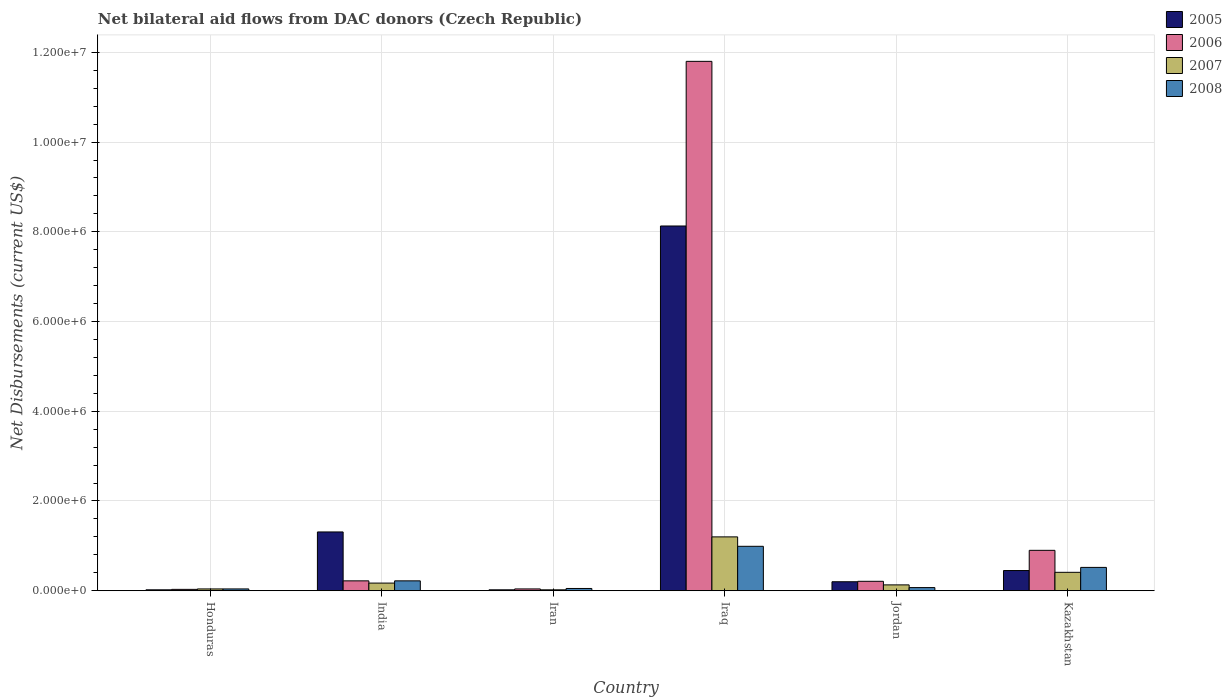How many different coloured bars are there?
Your answer should be compact. 4. How many groups of bars are there?
Give a very brief answer. 6. Are the number of bars per tick equal to the number of legend labels?
Offer a terse response. Yes. Are the number of bars on each tick of the X-axis equal?
Offer a terse response. Yes. How many bars are there on the 1st tick from the right?
Offer a very short reply. 4. What is the label of the 4th group of bars from the left?
Offer a terse response. Iraq. In how many cases, is the number of bars for a given country not equal to the number of legend labels?
Keep it short and to the point. 0. Across all countries, what is the maximum net bilateral aid flows in 2007?
Make the answer very short. 1.20e+06. In which country was the net bilateral aid flows in 2007 maximum?
Provide a short and direct response. Iraq. In which country was the net bilateral aid flows in 2007 minimum?
Offer a terse response. Iran. What is the total net bilateral aid flows in 2006 in the graph?
Keep it short and to the point. 1.32e+07. What is the difference between the net bilateral aid flows in 2005 in Honduras and that in India?
Make the answer very short. -1.29e+06. What is the difference between the net bilateral aid flows in 2007 in Honduras and the net bilateral aid flows in 2006 in Iraq?
Keep it short and to the point. -1.18e+07. What is the average net bilateral aid flows in 2007 per country?
Offer a very short reply. 3.28e+05. In how many countries, is the net bilateral aid flows in 2005 greater than 3200000 US$?
Give a very brief answer. 1. What is the ratio of the net bilateral aid flows in 2008 in Iraq to that in Kazakhstan?
Give a very brief answer. 1.9. Is the net bilateral aid flows in 2006 in Honduras less than that in Iran?
Provide a succinct answer. Yes. Is the difference between the net bilateral aid flows in 2008 in India and Iraq greater than the difference between the net bilateral aid flows in 2006 in India and Iraq?
Provide a succinct answer. Yes. What is the difference between the highest and the second highest net bilateral aid flows in 2005?
Keep it short and to the point. 6.82e+06. What is the difference between the highest and the lowest net bilateral aid flows in 2007?
Make the answer very short. 1.18e+06. Is it the case that in every country, the sum of the net bilateral aid flows in 2008 and net bilateral aid flows in 2005 is greater than the sum of net bilateral aid flows in 2006 and net bilateral aid flows in 2007?
Offer a very short reply. No. What does the 2nd bar from the right in India represents?
Provide a succinct answer. 2007. Is it the case that in every country, the sum of the net bilateral aid flows in 2006 and net bilateral aid flows in 2005 is greater than the net bilateral aid flows in 2007?
Your response must be concise. Yes. How many bars are there?
Make the answer very short. 24. Are all the bars in the graph horizontal?
Your answer should be compact. No. How many countries are there in the graph?
Provide a short and direct response. 6. Are the values on the major ticks of Y-axis written in scientific E-notation?
Ensure brevity in your answer.  Yes. What is the title of the graph?
Offer a very short reply. Net bilateral aid flows from DAC donors (Czech Republic). What is the label or title of the Y-axis?
Provide a succinct answer. Net Disbursements (current US$). What is the Net Disbursements (current US$) in 2006 in Honduras?
Provide a short and direct response. 3.00e+04. What is the Net Disbursements (current US$) in 2008 in Honduras?
Give a very brief answer. 4.00e+04. What is the Net Disbursements (current US$) in 2005 in India?
Your response must be concise. 1.31e+06. What is the Net Disbursements (current US$) of 2007 in India?
Offer a terse response. 1.70e+05. What is the Net Disbursements (current US$) of 2005 in Iran?
Give a very brief answer. 2.00e+04. What is the Net Disbursements (current US$) in 2008 in Iran?
Provide a short and direct response. 5.00e+04. What is the Net Disbursements (current US$) in 2005 in Iraq?
Your answer should be compact. 8.13e+06. What is the Net Disbursements (current US$) of 2006 in Iraq?
Offer a very short reply. 1.18e+07. What is the Net Disbursements (current US$) in 2007 in Iraq?
Offer a terse response. 1.20e+06. What is the Net Disbursements (current US$) in 2008 in Iraq?
Give a very brief answer. 9.90e+05. What is the Net Disbursements (current US$) in 2005 in Jordan?
Offer a terse response. 2.00e+05. What is the Net Disbursements (current US$) of 2007 in Kazakhstan?
Your response must be concise. 4.10e+05. What is the Net Disbursements (current US$) of 2008 in Kazakhstan?
Your answer should be very brief. 5.20e+05. Across all countries, what is the maximum Net Disbursements (current US$) in 2005?
Your answer should be very brief. 8.13e+06. Across all countries, what is the maximum Net Disbursements (current US$) in 2006?
Provide a succinct answer. 1.18e+07. Across all countries, what is the maximum Net Disbursements (current US$) in 2007?
Provide a short and direct response. 1.20e+06. Across all countries, what is the maximum Net Disbursements (current US$) in 2008?
Offer a terse response. 9.90e+05. Across all countries, what is the minimum Net Disbursements (current US$) in 2007?
Give a very brief answer. 2.00e+04. Across all countries, what is the minimum Net Disbursements (current US$) of 2008?
Ensure brevity in your answer.  4.00e+04. What is the total Net Disbursements (current US$) of 2005 in the graph?
Ensure brevity in your answer.  1.01e+07. What is the total Net Disbursements (current US$) of 2006 in the graph?
Ensure brevity in your answer.  1.32e+07. What is the total Net Disbursements (current US$) in 2007 in the graph?
Provide a short and direct response. 1.97e+06. What is the total Net Disbursements (current US$) of 2008 in the graph?
Provide a short and direct response. 1.89e+06. What is the difference between the Net Disbursements (current US$) in 2005 in Honduras and that in India?
Provide a succinct answer. -1.29e+06. What is the difference between the Net Disbursements (current US$) in 2006 in Honduras and that in India?
Your response must be concise. -1.90e+05. What is the difference between the Net Disbursements (current US$) of 2007 in Honduras and that in India?
Your answer should be compact. -1.30e+05. What is the difference between the Net Disbursements (current US$) of 2006 in Honduras and that in Iran?
Your answer should be compact. -10000. What is the difference between the Net Disbursements (current US$) in 2007 in Honduras and that in Iran?
Offer a very short reply. 2.00e+04. What is the difference between the Net Disbursements (current US$) in 2005 in Honduras and that in Iraq?
Offer a very short reply. -8.11e+06. What is the difference between the Net Disbursements (current US$) in 2006 in Honduras and that in Iraq?
Provide a succinct answer. -1.18e+07. What is the difference between the Net Disbursements (current US$) of 2007 in Honduras and that in Iraq?
Your answer should be compact. -1.16e+06. What is the difference between the Net Disbursements (current US$) in 2008 in Honduras and that in Iraq?
Provide a succinct answer. -9.50e+05. What is the difference between the Net Disbursements (current US$) in 2005 in Honduras and that in Jordan?
Provide a succinct answer. -1.80e+05. What is the difference between the Net Disbursements (current US$) of 2006 in Honduras and that in Jordan?
Offer a very short reply. -1.80e+05. What is the difference between the Net Disbursements (current US$) in 2007 in Honduras and that in Jordan?
Provide a succinct answer. -9.00e+04. What is the difference between the Net Disbursements (current US$) in 2008 in Honduras and that in Jordan?
Give a very brief answer. -3.00e+04. What is the difference between the Net Disbursements (current US$) of 2005 in Honduras and that in Kazakhstan?
Offer a very short reply. -4.30e+05. What is the difference between the Net Disbursements (current US$) of 2006 in Honduras and that in Kazakhstan?
Offer a terse response. -8.70e+05. What is the difference between the Net Disbursements (current US$) of 2007 in Honduras and that in Kazakhstan?
Offer a terse response. -3.70e+05. What is the difference between the Net Disbursements (current US$) in 2008 in Honduras and that in Kazakhstan?
Your response must be concise. -4.80e+05. What is the difference between the Net Disbursements (current US$) of 2005 in India and that in Iran?
Provide a short and direct response. 1.29e+06. What is the difference between the Net Disbursements (current US$) of 2005 in India and that in Iraq?
Provide a succinct answer. -6.82e+06. What is the difference between the Net Disbursements (current US$) of 2006 in India and that in Iraq?
Give a very brief answer. -1.16e+07. What is the difference between the Net Disbursements (current US$) of 2007 in India and that in Iraq?
Ensure brevity in your answer.  -1.03e+06. What is the difference between the Net Disbursements (current US$) of 2008 in India and that in Iraq?
Offer a very short reply. -7.70e+05. What is the difference between the Net Disbursements (current US$) in 2005 in India and that in Jordan?
Your answer should be compact. 1.11e+06. What is the difference between the Net Disbursements (current US$) in 2006 in India and that in Jordan?
Offer a very short reply. 10000. What is the difference between the Net Disbursements (current US$) of 2007 in India and that in Jordan?
Your answer should be compact. 4.00e+04. What is the difference between the Net Disbursements (current US$) in 2005 in India and that in Kazakhstan?
Offer a very short reply. 8.60e+05. What is the difference between the Net Disbursements (current US$) in 2006 in India and that in Kazakhstan?
Offer a terse response. -6.80e+05. What is the difference between the Net Disbursements (current US$) of 2005 in Iran and that in Iraq?
Your answer should be very brief. -8.11e+06. What is the difference between the Net Disbursements (current US$) of 2006 in Iran and that in Iraq?
Offer a very short reply. -1.18e+07. What is the difference between the Net Disbursements (current US$) in 2007 in Iran and that in Iraq?
Your response must be concise. -1.18e+06. What is the difference between the Net Disbursements (current US$) of 2008 in Iran and that in Iraq?
Give a very brief answer. -9.40e+05. What is the difference between the Net Disbursements (current US$) in 2005 in Iran and that in Jordan?
Your response must be concise. -1.80e+05. What is the difference between the Net Disbursements (current US$) in 2006 in Iran and that in Jordan?
Your response must be concise. -1.70e+05. What is the difference between the Net Disbursements (current US$) in 2007 in Iran and that in Jordan?
Provide a succinct answer. -1.10e+05. What is the difference between the Net Disbursements (current US$) of 2008 in Iran and that in Jordan?
Give a very brief answer. -2.00e+04. What is the difference between the Net Disbursements (current US$) of 2005 in Iran and that in Kazakhstan?
Ensure brevity in your answer.  -4.30e+05. What is the difference between the Net Disbursements (current US$) of 2006 in Iran and that in Kazakhstan?
Your answer should be compact. -8.60e+05. What is the difference between the Net Disbursements (current US$) of 2007 in Iran and that in Kazakhstan?
Ensure brevity in your answer.  -3.90e+05. What is the difference between the Net Disbursements (current US$) in 2008 in Iran and that in Kazakhstan?
Keep it short and to the point. -4.70e+05. What is the difference between the Net Disbursements (current US$) in 2005 in Iraq and that in Jordan?
Your answer should be compact. 7.93e+06. What is the difference between the Net Disbursements (current US$) in 2006 in Iraq and that in Jordan?
Keep it short and to the point. 1.16e+07. What is the difference between the Net Disbursements (current US$) of 2007 in Iraq and that in Jordan?
Offer a very short reply. 1.07e+06. What is the difference between the Net Disbursements (current US$) in 2008 in Iraq and that in Jordan?
Offer a very short reply. 9.20e+05. What is the difference between the Net Disbursements (current US$) of 2005 in Iraq and that in Kazakhstan?
Make the answer very short. 7.68e+06. What is the difference between the Net Disbursements (current US$) of 2006 in Iraq and that in Kazakhstan?
Give a very brief answer. 1.09e+07. What is the difference between the Net Disbursements (current US$) in 2007 in Iraq and that in Kazakhstan?
Keep it short and to the point. 7.90e+05. What is the difference between the Net Disbursements (current US$) of 2008 in Iraq and that in Kazakhstan?
Make the answer very short. 4.70e+05. What is the difference between the Net Disbursements (current US$) in 2006 in Jordan and that in Kazakhstan?
Make the answer very short. -6.90e+05. What is the difference between the Net Disbursements (current US$) of 2007 in Jordan and that in Kazakhstan?
Keep it short and to the point. -2.80e+05. What is the difference between the Net Disbursements (current US$) in 2008 in Jordan and that in Kazakhstan?
Provide a short and direct response. -4.50e+05. What is the difference between the Net Disbursements (current US$) in 2005 in Honduras and the Net Disbursements (current US$) in 2007 in India?
Your answer should be compact. -1.50e+05. What is the difference between the Net Disbursements (current US$) in 2005 in Honduras and the Net Disbursements (current US$) in 2008 in India?
Ensure brevity in your answer.  -2.00e+05. What is the difference between the Net Disbursements (current US$) of 2006 in Honduras and the Net Disbursements (current US$) of 2007 in India?
Keep it short and to the point. -1.40e+05. What is the difference between the Net Disbursements (current US$) of 2005 in Honduras and the Net Disbursements (current US$) of 2008 in Iran?
Offer a very short reply. -3.00e+04. What is the difference between the Net Disbursements (current US$) in 2006 in Honduras and the Net Disbursements (current US$) in 2008 in Iran?
Your response must be concise. -2.00e+04. What is the difference between the Net Disbursements (current US$) of 2005 in Honduras and the Net Disbursements (current US$) of 2006 in Iraq?
Offer a terse response. -1.18e+07. What is the difference between the Net Disbursements (current US$) of 2005 in Honduras and the Net Disbursements (current US$) of 2007 in Iraq?
Provide a succinct answer. -1.18e+06. What is the difference between the Net Disbursements (current US$) of 2005 in Honduras and the Net Disbursements (current US$) of 2008 in Iraq?
Ensure brevity in your answer.  -9.70e+05. What is the difference between the Net Disbursements (current US$) in 2006 in Honduras and the Net Disbursements (current US$) in 2007 in Iraq?
Keep it short and to the point. -1.17e+06. What is the difference between the Net Disbursements (current US$) of 2006 in Honduras and the Net Disbursements (current US$) of 2008 in Iraq?
Ensure brevity in your answer.  -9.60e+05. What is the difference between the Net Disbursements (current US$) in 2007 in Honduras and the Net Disbursements (current US$) in 2008 in Iraq?
Ensure brevity in your answer.  -9.50e+05. What is the difference between the Net Disbursements (current US$) of 2005 in Honduras and the Net Disbursements (current US$) of 2006 in Jordan?
Your answer should be very brief. -1.90e+05. What is the difference between the Net Disbursements (current US$) of 2005 in Honduras and the Net Disbursements (current US$) of 2007 in Jordan?
Your answer should be compact. -1.10e+05. What is the difference between the Net Disbursements (current US$) in 2006 in Honduras and the Net Disbursements (current US$) in 2007 in Jordan?
Provide a short and direct response. -1.00e+05. What is the difference between the Net Disbursements (current US$) in 2006 in Honduras and the Net Disbursements (current US$) in 2008 in Jordan?
Provide a short and direct response. -4.00e+04. What is the difference between the Net Disbursements (current US$) of 2005 in Honduras and the Net Disbursements (current US$) of 2006 in Kazakhstan?
Give a very brief answer. -8.80e+05. What is the difference between the Net Disbursements (current US$) in 2005 in Honduras and the Net Disbursements (current US$) in 2007 in Kazakhstan?
Provide a succinct answer. -3.90e+05. What is the difference between the Net Disbursements (current US$) of 2005 in Honduras and the Net Disbursements (current US$) of 2008 in Kazakhstan?
Offer a very short reply. -5.00e+05. What is the difference between the Net Disbursements (current US$) in 2006 in Honduras and the Net Disbursements (current US$) in 2007 in Kazakhstan?
Make the answer very short. -3.80e+05. What is the difference between the Net Disbursements (current US$) in 2006 in Honduras and the Net Disbursements (current US$) in 2008 in Kazakhstan?
Your answer should be compact. -4.90e+05. What is the difference between the Net Disbursements (current US$) in 2007 in Honduras and the Net Disbursements (current US$) in 2008 in Kazakhstan?
Your answer should be compact. -4.80e+05. What is the difference between the Net Disbursements (current US$) in 2005 in India and the Net Disbursements (current US$) in 2006 in Iran?
Make the answer very short. 1.27e+06. What is the difference between the Net Disbursements (current US$) in 2005 in India and the Net Disbursements (current US$) in 2007 in Iran?
Provide a short and direct response. 1.29e+06. What is the difference between the Net Disbursements (current US$) of 2005 in India and the Net Disbursements (current US$) of 2008 in Iran?
Make the answer very short. 1.26e+06. What is the difference between the Net Disbursements (current US$) of 2006 in India and the Net Disbursements (current US$) of 2008 in Iran?
Provide a succinct answer. 1.70e+05. What is the difference between the Net Disbursements (current US$) of 2005 in India and the Net Disbursements (current US$) of 2006 in Iraq?
Your answer should be compact. -1.05e+07. What is the difference between the Net Disbursements (current US$) in 2005 in India and the Net Disbursements (current US$) in 2008 in Iraq?
Offer a very short reply. 3.20e+05. What is the difference between the Net Disbursements (current US$) in 2006 in India and the Net Disbursements (current US$) in 2007 in Iraq?
Keep it short and to the point. -9.80e+05. What is the difference between the Net Disbursements (current US$) in 2006 in India and the Net Disbursements (current US$) in 2008 in Iraq?
Your answer should be compact. -7.70e+05. What is the difference between the Net Disbursements (current US$) in 2007 in India and the Net Disbursements (current US$) in 2008 in Iraq?
Offer a terse response. -8.20e+05. What is the difference between the Net Disbursements (current US$) of 2005 in India and the Net Disbursements (current US$) of 2006 in Jordan?
Give a very brief answer. 1.10e+06. What is the difference between the Net Disbursements (current US$) of 2005 in India and the Net Disbursements (current US$) of 2007 in Jordan?
Offer a terse response. 1.18e+06. What is the difference between the Net Disbursements (current US$) of 2005 in India and the Net Disbursements (current US$) of 2008 in Jordan?
Give a very brief answer. 1.24e+06. What is the difference between the Net Disbursements (current US$) in 2006 in India and the Net Disbursements (current US$) in 2007 in Jordan?
Ensure brevity in your answer.  9.00e+04. What is the difference between the Net Disbursements (current US$) of 2007 in India and the Net Disbursements (current US$) of 2008 in Jordan?
Make the answer very short. 1.00e+05. What is the difference between the Net Disbursements (current US$) of 2005 in India and the Net Disbursements (current US$) of 2008 in Kazakhstan?
Offer a very short reply. 7.90e+05. What is the difference between the Net Disbursements (current US$) of 2006 in India and the Net Disbursements (current US$) of 2007 in Kazakhstan?
Ensure brevity in your answer.  -1.90e+05. What is the difference between the Net Disbursements (current US$) of 2006 in India and the Net Disbursements (current US$) of 2008 in Kazakhstan?
Provide a succinct answer. -3.00e+05. What is the difference between the Net Disbursements (current US$) of 2007 in India and the Net Disbursements (current US$) of 2008 in Kazakhstan?
Provide a short and direct response. -3.50e+05. What is the difference between the Net Disbursements (current US$) of 2005 in Iran and the Net Disbursements (current US$) of 2006 in Iraq?
Offer a very short reply. -1.18e+07. What is the difference between the Net Disbursements (current US$) of 2005 in Iran and the Net Disbursements (current US$) of 2007 in Iraq?
Ensure brevity in your answer.  -1.18e+06. What is the difference between the Net Disbursements (current US$) of 2005 in Iran and the Net Disbursements (current US$) of 2008 in Iraq?
Offer a very short reply. -9.70e+05. What is the difference between the Net Disbursements (current US$) in 2006 in Iran and the Net Disbursements (current US$) in 2007 in Iraq?
Ensure brevity in your answer.  -1.16e+06. What is the difference between the Net Disbursements (current US$) in 2006 in Iran and the Net Disbursements (current US$) in 2008 in Iraq?
Make the answer very short. -9.50e+05. What is the difference between the Net Disbursements (current US$) of 2007 in Iran and the Net Disbursements (current US$) of 2008 in Iraq?
Provide a succinct answer. -9.70e+05. What is the difference between the Net Disbursements (current US$) in 2005 in Iran and the Net Disbursements (current US$) in 2006 in Jordan?
Offer a terse response. -1.90e+05. What is the difference between the Net Disbursements (current US$) of 2006 in Iran and the Net Disbursements (current US$) of 2008 in Jordan?
Give a very brief answer. -3.00e+04. What is the difference between the Net Disbursements (current US$) of 2007 in Iran and the Net Disbursements (current US$) of 2008 in Jordan?
Offer a terse response. -5.00e+04. What is the difference between the Net Disbursements (current US$) in 2005 in Iran and the Net Disbursements (current US$) in 2006 in Kazakhstan?
Offer a very short reply. -8.80e+05. What is the difference between the Net Disbursements (current US$) of 2005 in Iran and the Net Disbursements (current US$) of 2007 in Kazakhstan?
Your answer should be very brief. -3.90e+05. What is the difference between the Net Disbursements (current US$) in 2005 in Iran and the Net Disbursements (current US$) in 2008 in Kazakhstan?
Give a very brief answer. -5.00e+05. What is the difference between the Net Disbursements (current US$) of 2006 in Iran and the Net Disbursements (current US$) of 2007 in Kazakhstan?
Provide a succinct answer. -3.70e+05. What is the difference between the Net Disbursements (current US$) in 2006 in Iran and the Net Disbursements (current US$) in 2008 in Kazakhstan?
Provide a succinct answer. -4.80e+05. What is the difference between the Net Disbursements (current US$) in 2007 in Iran and the Net Disbursements (current US$) in 2008 in Kazakhstan?
Offer a terse response. -5.00e+05. What is the difference between the Net Disbursements (current US$) of 2005 in Iraq and the Net Disbursements (current US$) of 2006 in Jordan?
Make the answer very short. 7.92e+06. What is the difference between the Net Disbursements (current US$) in 2005 in Iraq and the Net Disbursements (current US$) in 2007 in Jordan?
Keep it short and to the point. 8.00e+06. What is the difference between the Net Disbursements (current US$) of 2005 in Iraq and the Net Disbursements (current US$) of 2008 in Jordan?
Provide a short and direct response. 8.06e+06. What is the difference between the Net Disbursements (current US$) of 2006 in Iraq and the Net Disbursements (current US$) of 2007 in Jordan?
Provide a short and direct response. 1.17e+07. What is the difference between the Net Disbursements (current US$) of 2006 in Iraq and the Net Disbursements (current US$) of 2008 in Jordan?
Your answer should be very brief. 1.17e+07. What is the difference between the Net Disbursements (current US$) in 2007 in Iraq and the Net Disbursements (current US$) in 2008 in Jordan?
Make the answer very short. 1.13e+06. What is the difference between the Net Disbursements (current US$) of 2005 in Iraq and the Net Disbursements (current US$) of 2006 in Kazakhstan?
Provide a short and direct response. 7.23e+06. What is the difference between the Net Disbursements (current US$) in 2005 in Iraq and the Net Disbursements (current US$) in 2007 in Kazakhstan?
Ensure brevity in your answer.  7.72e+06. What is the difference between the Net Disbursements (current US$) in 2005 in Iraq and the Net Disbursements (current US$) in 2008 in Kazakhstan?
Ensure brevity in your answer.  7.61e+06. What is the difference between the Net Disbursements (current US$) in 2006 in Iraq and the Net Disbursements (current US$) in 2007 in Kazakhstan?
Give a very brief answer. 1.14e+07. What is the difference between the Net Disbursements (current US$) of 2006 in Iraq and the Net Disbursements (current US$) of 2008 in Kazakhstan?
Make the answer very short. 1.13e+07. What is the difference between the Net Disbursements (current US$) of 2007 in Iraq and the Net Disbursements (current US$) of 2008 in Kazakhstan?
Give a very brief answer. 6.80e+05. What is the difference between the Net Disbursements (current US$) in 2005 in Jordan and the Net Disbursements (current US$) in 2006 in Kazakhstan?
Ensure brevity in your answer.  -7.00e+05. What is the difference between the Net Disbursements (current US$) of 2005 in Jordan and the Net Disbursements (current US$) of 2007 in Kazakhstan?
Offer a terse response. -2.10e+05. What is the difference between the Net Disbursements (current US$) in 2005 in Jordan and the Net Disbursements (current US$) in 2008 in Kazakhstan?
Give a very brief answer. -3.20e+05. What is the difference between the Net Disbursements (current US$) in 2006 in Jordan and the Net Disbursements (current US$) in 2007 in Kazakhstan?
Your response must be concise. -2.00e+05. What is the difference between the Net Disbursements (current US$) of 2006 in Jordan and the Net Disbursements (current US$) of 2008 in Kazakhstan?
Your answer should be very brief. -3.10e+05. What is the difference between the Net Disbursements (current US$) of 2007 in Jordan and the Net Disbursements (current US$) of 2008 in Kazakhstan?
Your answer should be compact. -3.90e+05. What is the average Net Disbursements (current US$) in 2005 per country?
Keep it short and to the point. 1.69e+06. What is the average Net Disbursements (current US$) of 2006 per country?
Provide a succinct answer. 2.20e+06. What is the average Net Disbursements (current US$) of 2007 per country?
Make the answer very short. 3.28e+05. What is the average Net Disbursements (current US$) of 2008 per country?
Offer a very short reply. 3.15e+05. What is the difference between the Net Disbursements (current US$) of 2005 and Net Disbursements (current US$) of 2008 in Honduras?
Keep it short and to the point. -2.00e+04. What is the difference between the Net Disbursements (current US$) in 2007 and Net Disbursements (current US$) in 2008 in Honduras?
Make the answer very short. 0. What is the difference between the Net Disbursements (current US$) in 2005 and Net Disbursements (current US$) in 2006 in India?
Make the answer very short. 1.09e+06. What is the difference between the Net Disbursements (current US$) in 2005 and Net Disbursements (current US$) in 2007 in India?
Ensure brevity in your answer.  1.14e+06. What is the difference between the Net Disbursements (current US$) of 2005 and Net Disbursements (current US$) of 2008 in India?
Offer a terse response. 1.09e+06. What is the difference between the Net Disbursements (current US$) of 2006 and Net Disbursements (current US$) of 2007 in India?
Your answer should be very brief. 5.00e+04. What is the difference between the Net Disbursements (current US$) in 2006 and Net Disbursements (current US$) in 2008 in India?
Offer a terse response. 0. What is the difference between the Net Disbursements (current US$) of 2007 and Net Disbursements (current US$) of 2008 in India?
Give a very brief answer. -5.00e+04. What is the difference between the Net Disbursements (current US$) of 2005 and Net Disbursements (current US$) of 2007 in Iran?
Your answer should be compact. 0. What is the difference between the Net Disbursements (current US$) of 2005 and Net Disbursements (current US$) of 2008 in Iran?
Offer a terse response. -3.00e+04. What is the difference between the Net Disbursements (current US$) in 2006 and Net Disbursements (current US$) in 2007 in Iran?
Make the answer very short. 2.00e+04. What is the difference between the Net Disbursements (current US$) in 2006 and Net Disbursements (current US$) in 2008 in Iran?
Your answer should be compact. -10000. What is the difference between the Net Disbursements (current US$) of 2007 and Net Disbursements (current US$) of 2008 in Iran?
Your answer should be compact. -3.00e+04. What is the difference between the Net Disbursements (current US$) of 2005 and Net Disbursements (current US$) of 2006 in Iraq?
Provide a short and direct response. -3.67e+06. What is the difference between the Net Disbursements (current US$) of 2005 and Net Disbursements (current US$) of 2007 in Iraq?
Your answer should be compact. 6.93e+06. What is the difference between the Net Disbursements (current US$) of 2005 and Net Disbursements (current US$) of 2008 in Iraq?
Ensure brevity in your answer.  7.14e+06. What is the difference between the Net Disbursements (current US$) of 2006 and Net Disbursements (current US$) of 2007 in Iraq?
Your answer should be compact. 1.06e+07. What is the difference between the Net Disbursements (current US$) in 2006 and Net Disbursements (current US$) in 2008 in Iraq?
Offer a terse response. 1.08e+07. What is the difference between the Net Disbursements (current US$) of 2007 and Net Disbursements (current US$) of 2008 in Iraq?
Provide a short and direct response. 2.10e+05. What is the difference between the Net Disbursements (current US$) in 2005 and Net Disbursements (current US$) in 2008 in Jordan?
Make the answer very short. 1.30e+05. What is the difference between the Net Disbursements (current US$) of 2006 and Net Disbursements (current US$) of 2007 in Jordan?
Give a very brief answer. 8.00e+04. What is the difference between the Net Disbursements (current US$) of 2006 and Net Disbursements (current US$) of 2008 in Jordan?
Offer a very short reply. 1.40e+05. What is the difference between the Net Disbursements (current US$) in 2005 and Net Disbursements (current US$) in 2006 in Kazakhstan?
Your answer should be very brief. -4.50e+05. What is the difference between the Net Disbursements (current US$) of 2007 and Net Disbursements (current US$) of 2008 in Kazakhstan?
Ensure brevity in your answer.  -1.10e+05. What is the ratio of the Net Disbursements (current US$) in 2005 in Honduras to that in India?
Provide a short and direct response. 0.02. What is the ratio of the Net Disbursements (current US$) in 2006 in Honduras to that in India?
Offer a terse response. 0.14. What is the ratio of the Net Disbursements (current US$) of 2007 in Honduras to that in India?
Offer a very short reply. 0.24. What is the ratio of the Net Disbursements (current US$) in 2008 in Honduras to that in India?
Your answer should be compact. 0.18. What is the ratio of the Net Disbursements (current US$) in 2006 in Honduras to that in Iran?
Provide a succinct answer. 0.75. What is the ratio of the Net Disbursements (current US$) of 2005 in Honduras to that in Iraq?
Make the answer very short. 0. What is the ratio of the Net Disbursements (current US$) in 2006 in Honduras to that in Iraq?
Give a very brief answer. 0. What is the ratio of the Net Disbursements (current US$) in 2008 in Honduras to that in Iraq?
Offer a terse response. 0.04. What is the ratio of the Net Disbursements (current US$) of 2006 in Honduras to that in Jordan?
Keep it short and to the point. 0.14. What is the ratio of the Net Disbursements (current US$) in 2007 in Honduras to that in Jordan?
Ensure brevity in your answer.  0.31. What is the ratio of the Net Disbursements (current US$) of 2005 in Honduras to that in Kazakhstan?
Give a very brief answer. 0.04. What is the ratio of the Net Disbursements (current US$) of 2007 in Honduras to that in Kazakhstan?
Offer a terse response. 0.1. What is the ratio of the Net Disbursements (current US$) of 2008 in Honduras to that in Kazakhstan?
Offer a very short reply. 0.08. What is the ratio of the Net Disbursements (current US$) in 2005 in India to that in Iran?
Offer a terse response. 65.5. What is the ratio of the Net Disbursements (current US$) of 2007 in India to that in Iran?
Offer a very short reply. 8.5. What is the ratio of the Net Disbursements (current US$) in 2008 in India to that in Iran?
Offer a very short reply. 4.4. What is the ratio of the Net Disbursements (current US$) of 2005 in India to that in Iraq?
Make the answer very short. 0.16. What is the ratio of the Net Disbursements (current US$) in 2006 in India to that in Iraq?
Your response must be concise. 0.02. What is the ratio of the Net Disbursements (current US$) in 2007 in India to that in Iraq?
Make the answer very short. 0.14. What is the ratio of the Net Disbursements (current US$) in 2008 in India to that in Iraq?
Offer a very short reply. 0.22. What is the ratio of the Net Disbursements (current US$) in 2005 in India to that in Jordan?
Offer a terse response. 6.55. What is the ratio of the Net Disbursements (current US$) of 2006 in India to that in Jordan?
Ensure brevity in your answer.  1.05. What is the ratio of the Net Disbursements (current US$) of 2007 in India to that in Jordan?
Your response must be concise. 1.31. What is the ratio of the Net Disbursements (current US$) in 2008 in India to that in Jordan?
Your answer should be compact. 3.14. What is the ratio of the Net Disbursements (current US$) of 2005 in India to that in Kazakhstan?
Your response must be concise. 2.91. What is the ratio of the Net Disbursements (current US$) in 2006 in India to that in Kazakhstan?
Offer a very short reply. 0.24. What is the ratio of the Net Disbursements (current US$) in 2007 in India to that in Kazakhstan?
Offer a terse response. 0.41. What is the ratio of the Net Disbursements (current US$) in 2008 in India to that in Kazakhstan?
Keep it short and to the point. 0.42. What is the ratio of the Net Disbursements (current US$) of 2005 in Iran to that in Iraq?
Your answer should be very brief. 0. What is the ratio of the Net Disbursements (current US$) in 2006 in Iran to that in Iraq?
Provide a short and direct response. 0. What is the ratio of the Net Disbursements (current US$) in 2007 in Iran to that in Iraq?
Offer a very short reply. 0.02. What is the ratio of the Net Disbursements (current US$) in 2008 in Iran to that in Iraq?
Offer a terse response. 0.05. What is the ratio of the Net Disbursements (current US$) in 2006 in Iran to that in Jordan?
Your answer should be very brief. 0.19. What is the ratio of the Net Disbursements (current US$) of 2007 in Iran to that in Jordan?
Give a very brief answer. 0.15. What is the ratio of the Net Disbursements (current US$) in 2005 in Iran to that in Kazakhstan?
Offer a terse response. 0.04. What is the ratio of the Net Disbursements (current US$) in 2006 in Iran to that in Kazakhstan?
Give a very brief answer. 0.04. What is the ratio of the Net Disbursements (current US$) of 2007 in Iran to that in Kazakhstan?
Offer a very short reply. 0.05. What is the ratio of the Net Disbursements (current US$) in 2008 in Iran to that in Kazakhstan?
Your answer should be compact. 0.1. What is the ratio of the Net Disbursements (current US$) in 2005 in Iraq to that in Jordan?
Provide a short and direct response. 40.65. What is the ratio of the Net Disbursements (current US$) of 2006 in Iraq to that in Jordan?
Give a very brief answer. 56.19. What is the ratio of the Net Disbursements (current US$) of 2007 in Iraq to that in Jordan?
Your answer should be very brief. 9.23. What is the ratio of the Net Disbursements (current US$) of 2008 in Iraq to that in Jordan?
Offer a terse response. 14.14. What is the ratio of the Net Disbursements (current US$) of 2005 in Iraq to that in Kazakhstan?
Offer a very short reply. 18.07. What is the ratio of the Net Disbursements (current US$) in 2006 in Iraq to that in Kazakhstan?
Provide a succinct answer. 13.11. What is the ratio of the Net Disbursements (current US$) in 2007 in Iraq to that in Kazakhstan?
Keep it short and to the point. 2.93. What is the ratio of the Net Disbursements (current US$) of 2008 in Iraq to that in Kazakhstan?
Your response must be concise. 1.9. What is the ratio of the Net Disbursements (current US$) in 2005 in Jordan to that in Kazakhstan?
Your answer should be compact. 0.44. What is the ratio of the Net Disbursements (current US$) of 2006 in Jordan to that in Kazakhstan?
Your response must be concise. 0.23. What is the ratio of the Net Disbursements (current US$) in 2007 in Jordan to that in Kazakhstan?
Your answer should be compact. 0.32. What is the ratio of the Net Disbursements (current US$) in 2008 in Jordan to that in Kazakhstan?
Your answer should be compact. 0.13. What is the difference between the highest and the second highest Net Disbursements (current US$) in 2005?
Provide a short and direct response. 6.82e+06. What is the difference between the highest and the second highest Net Disbursements (current US$) of 2006?
Keep it short and to the point. 1.09e+07. What is the difference between the highest and the second highest Net Disbursements (current US$) in 2007?
Your answer should be compact. 7.90e+05. What is the difference between the highest and the lowest Net Disbursements (current US$) in 2005?
Your answer should be very brief. 8.11e+06. What is the difference between the highest and the lowest Net Disbursements (current US$) in 2006?
Give a very brief answer. 1.18e+07. What is the difference between the highest and the lowest Net Disbursements (current US$) of 2007?
Your response must be concise. 1.18e+06. What is the difference between the highest and the lowest Net Disbursements (current US$) of 2008?
Make the answer very short. 9.50e+05. 